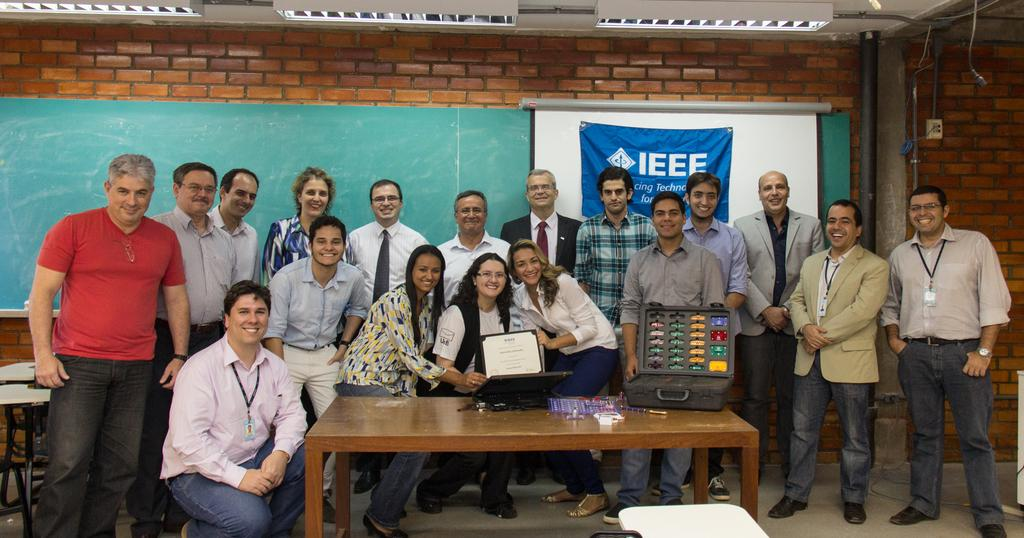How many people are in the image? There is a group of people in the image, but the exact number is not specified. What can be seen on the table in the image? There is a device on a table in the image. What is on the wall in the image? There is a blackboard on the wall in the image. What is the source of light in the image? There is a light at the top of the image. What rule does the father enforce in the image? There is no mention of a father or any rules in the image. How does the light blow out in the image? The light does not blow out in the image; it is a source of light. 